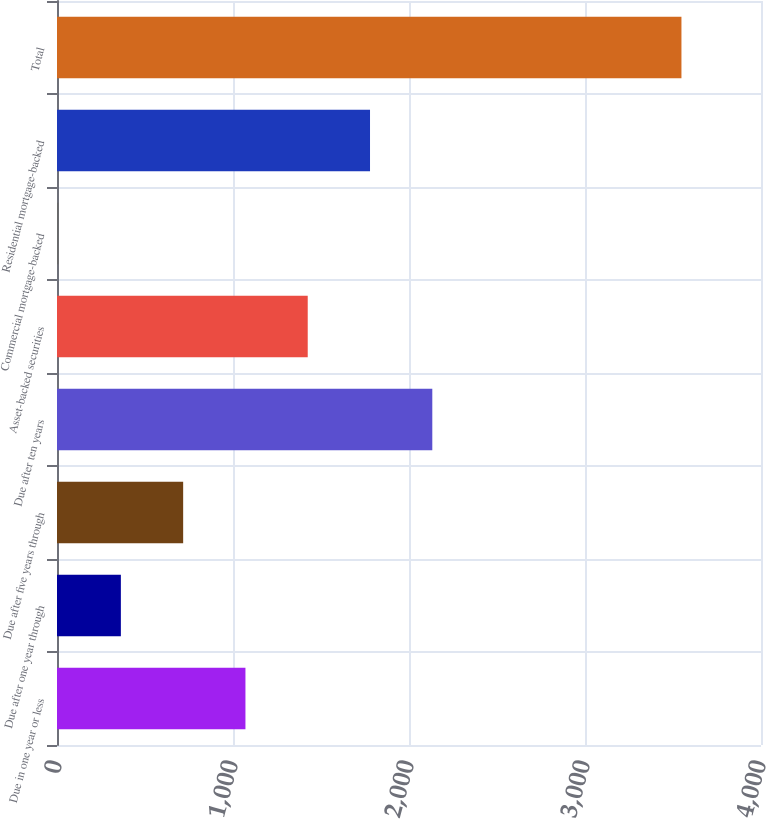Convert chart. <chart><loc_0><loc_0><loc_500><loc_500><bar_chart><fcel>Due in one year or less<fcel>Due after one year through<fcel>Due after five years through<fcel>Due after ten years<fcel>Asset-backed securities<fcel>Commercial mortgage-backed<fcel>Residential mortgage-backed<fcel>Total<nl><fcel>1070.7<fcel>362.9<fcel>716.8<fcel>2132.4<fcel>1424.6<fcel>9<fcel>1778.5<fcel>3548<nl></chart> 